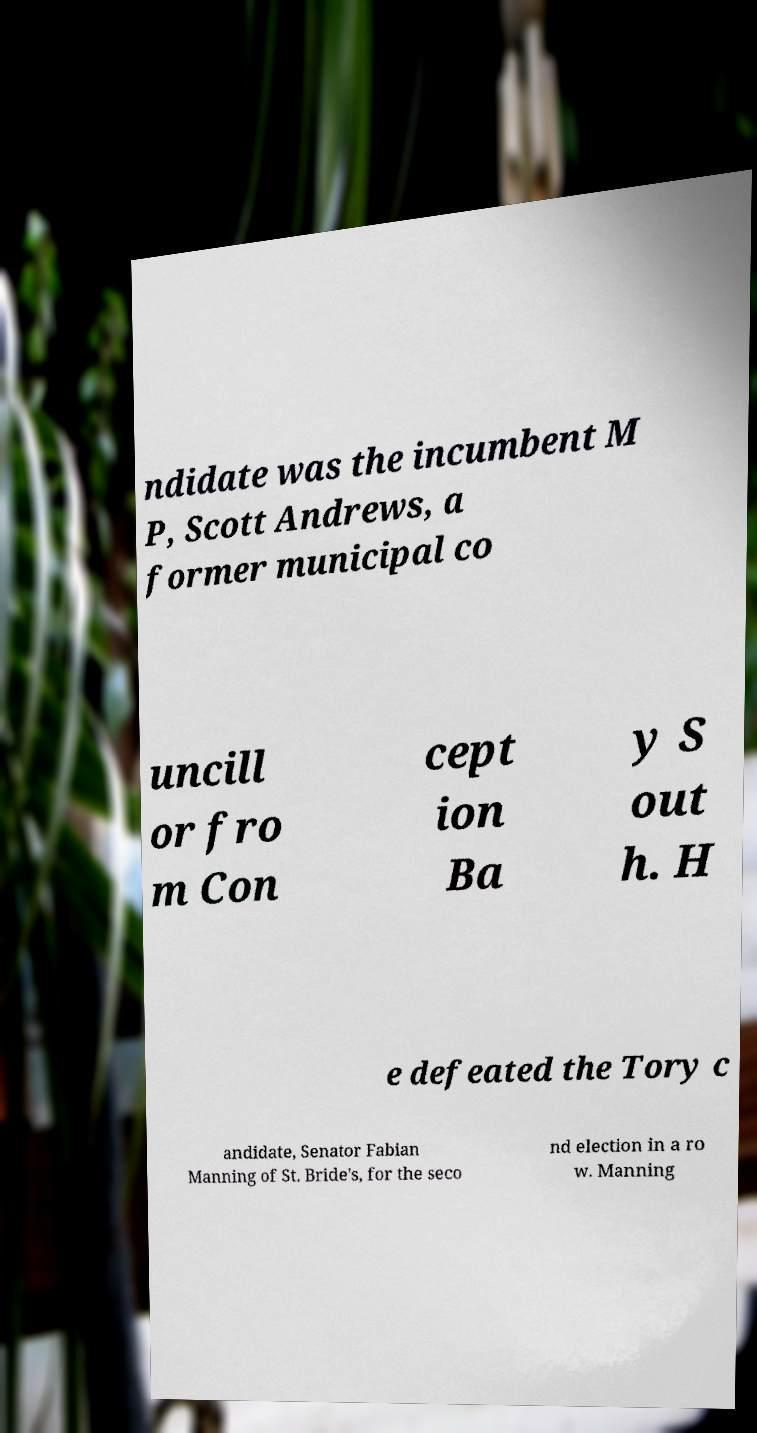Could you assist in decoding the text presented in this image and type it out clearly? ndidate was the incumbent M P, Scott Andrews, a former municipal co uncill or fro m Con cept ion Ba y S out h. H e defeated the Tory c andidate, Senator Fabian Manning of St. Bride's, for the seco nd election in a ro w. Manning 